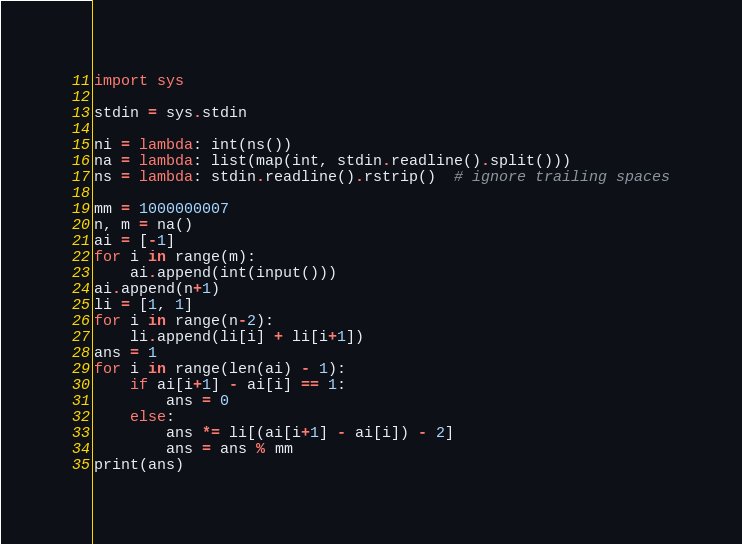<code> <loc_0><loc_0><loc_500><loc_500><_Python_>import sys

stdin = sys.stdin

ni = lambda: int(ns())
na = lambda: list(map(int, stdin.readline().split()))
ns = lambda: stdin.readline().rstrip()  # ignore trailing spaces

mm = 1000000007
n, m = na()
ai = [-1]
for i in range(m):
    ai.append(int(input()))
ai.append(n+1)
li = [1, 1]
for i in range(n-2):
    li.append(li[i] + li[i+1])
ans = 1
for i in range(len(ai) - 1):
    if ai[i+1] - ai[i] == 1:
        ans = 0
    else:
        ans *= li[(ai[i+1] - ai[i]) - 2]
        ans = ans % mm
print(ans)</code> 